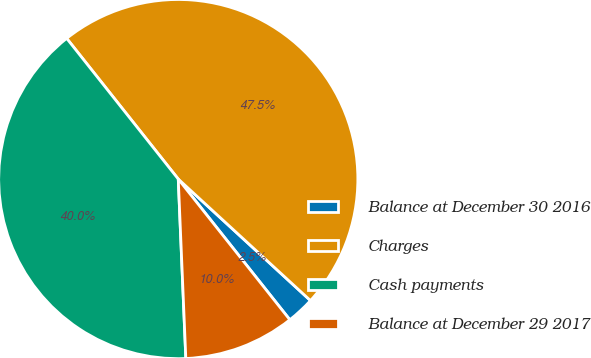<chart> <loc_0><loc_0><loc_500><loc_500><pie_chart><fcel>Balance at December 30 2016<fcel>Charges<fcel>Cash payments<fcel>Balance at December 29 2017<nl><fcel>2.5%<fcel>47.5%<fcel>40.0%<fcel>10.0%<nl></chart> 